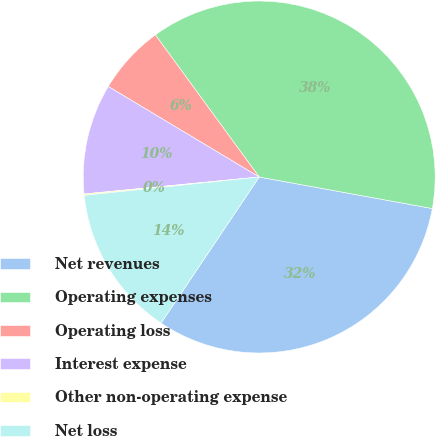Convert chart. <chart><loc_0><loc_0><loc_500><loc_500><pie_chart><fcel>Net revenues<fcel>Operating expenses<fcel>Operating loss<fcel>Interest expense<fcel>Other non-operating expense<fcel>Net loss<nl><fcel>31.55%<fcel>37.91%<fcel>6.36%<fcel>10.14%<fcel>0.13%<fcel>13.92%<nl></chart> 